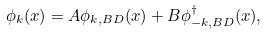<formula> <loc_0><loc_0><loc_500><loc_500>\phi _ { k } ( x ) = A \phi _ { k , B D } ( x ) + B \phi _ { - k , B D } ^ { \dagger } ( x ) ,</formula> 